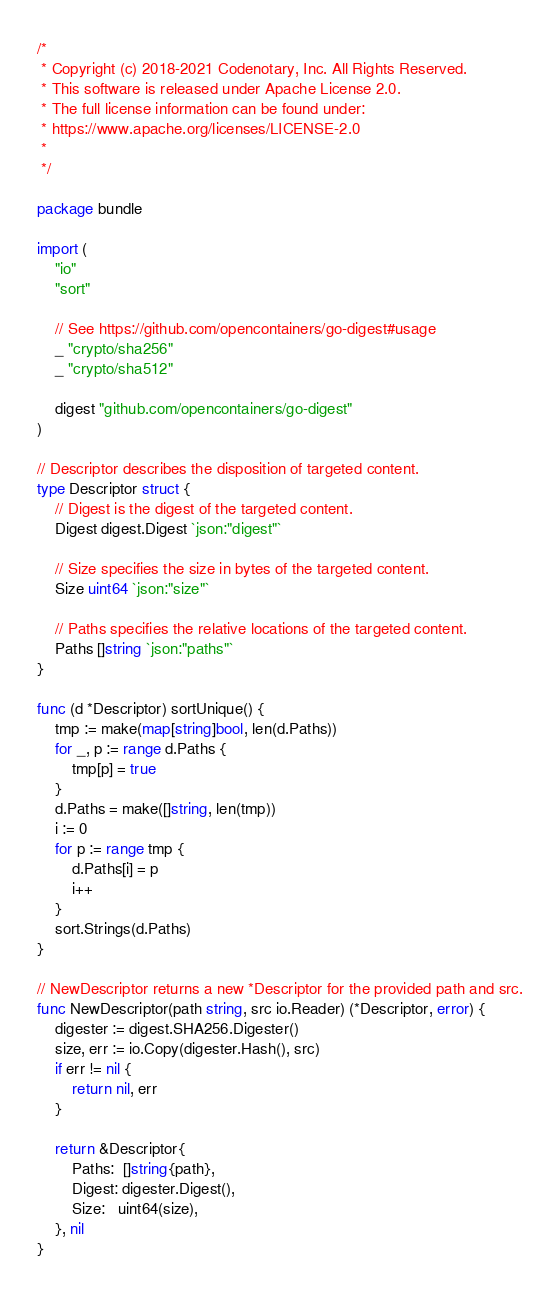Convert code to text. <code><loc_0><loc_0><loc_500><loc_500><_Go_>/*
 * Copyright (c) 2018-2021 Codenotary, Inc. All Rights Reserved.
 * This software is released under Apache License 2.0.
 * The full license information can be found under:
 * https://www.apache.org/licenses/LICENSE-2.0
 *
 */

package bundle

import (
	"io"
	"sort"

	// See https://github.com/opencontainers/go-digest#usage
	_ "crypto/sha256"
	_ "crypto/sha512"

	digest "github.com/opencontainers/go-digest"
)

// Descriptor describes the disposition of targeted content.
type Descriptor struct {
	// Digest is the digest of the targeted content.
	Digest digest.Digest `json:"digest"`

	// Size specifies the size in bytes of the targeted content.
	Size uint64 `json:"size"`

	// Paths specifies the relative locations of the targeted content.
	Paths []string `json:"paths"`
}

func (d *Descriptor) sortUnique() {
	tmp := make(map[string]bool, len(d.Paths))
	for _, p := range d.Paths {
		tmp[p] = true
	}
	d.Paths = make([]string, len(tmp))
	i := 0
	for p := range tmp {
		d.Paths[i] = p
		i++
	}
	sort.Strings(d.Paths)
}

// NewDescriptor returns a new *Descriptor for the provided path and src.
func NewDescriptor(path string, src io.Reader) (*Descriptor, error) {
	digester := digest.SHA256.Digester()
	size, err := io.Copy(digester.Hash(), src)
	if err != nil {
		return nil, err
	}

	return &Descriptor{
		Paths:  []string{path},
		Digest: digester.Digest(),
		Size:   uint64(size),
	}, nil
}
</code> 